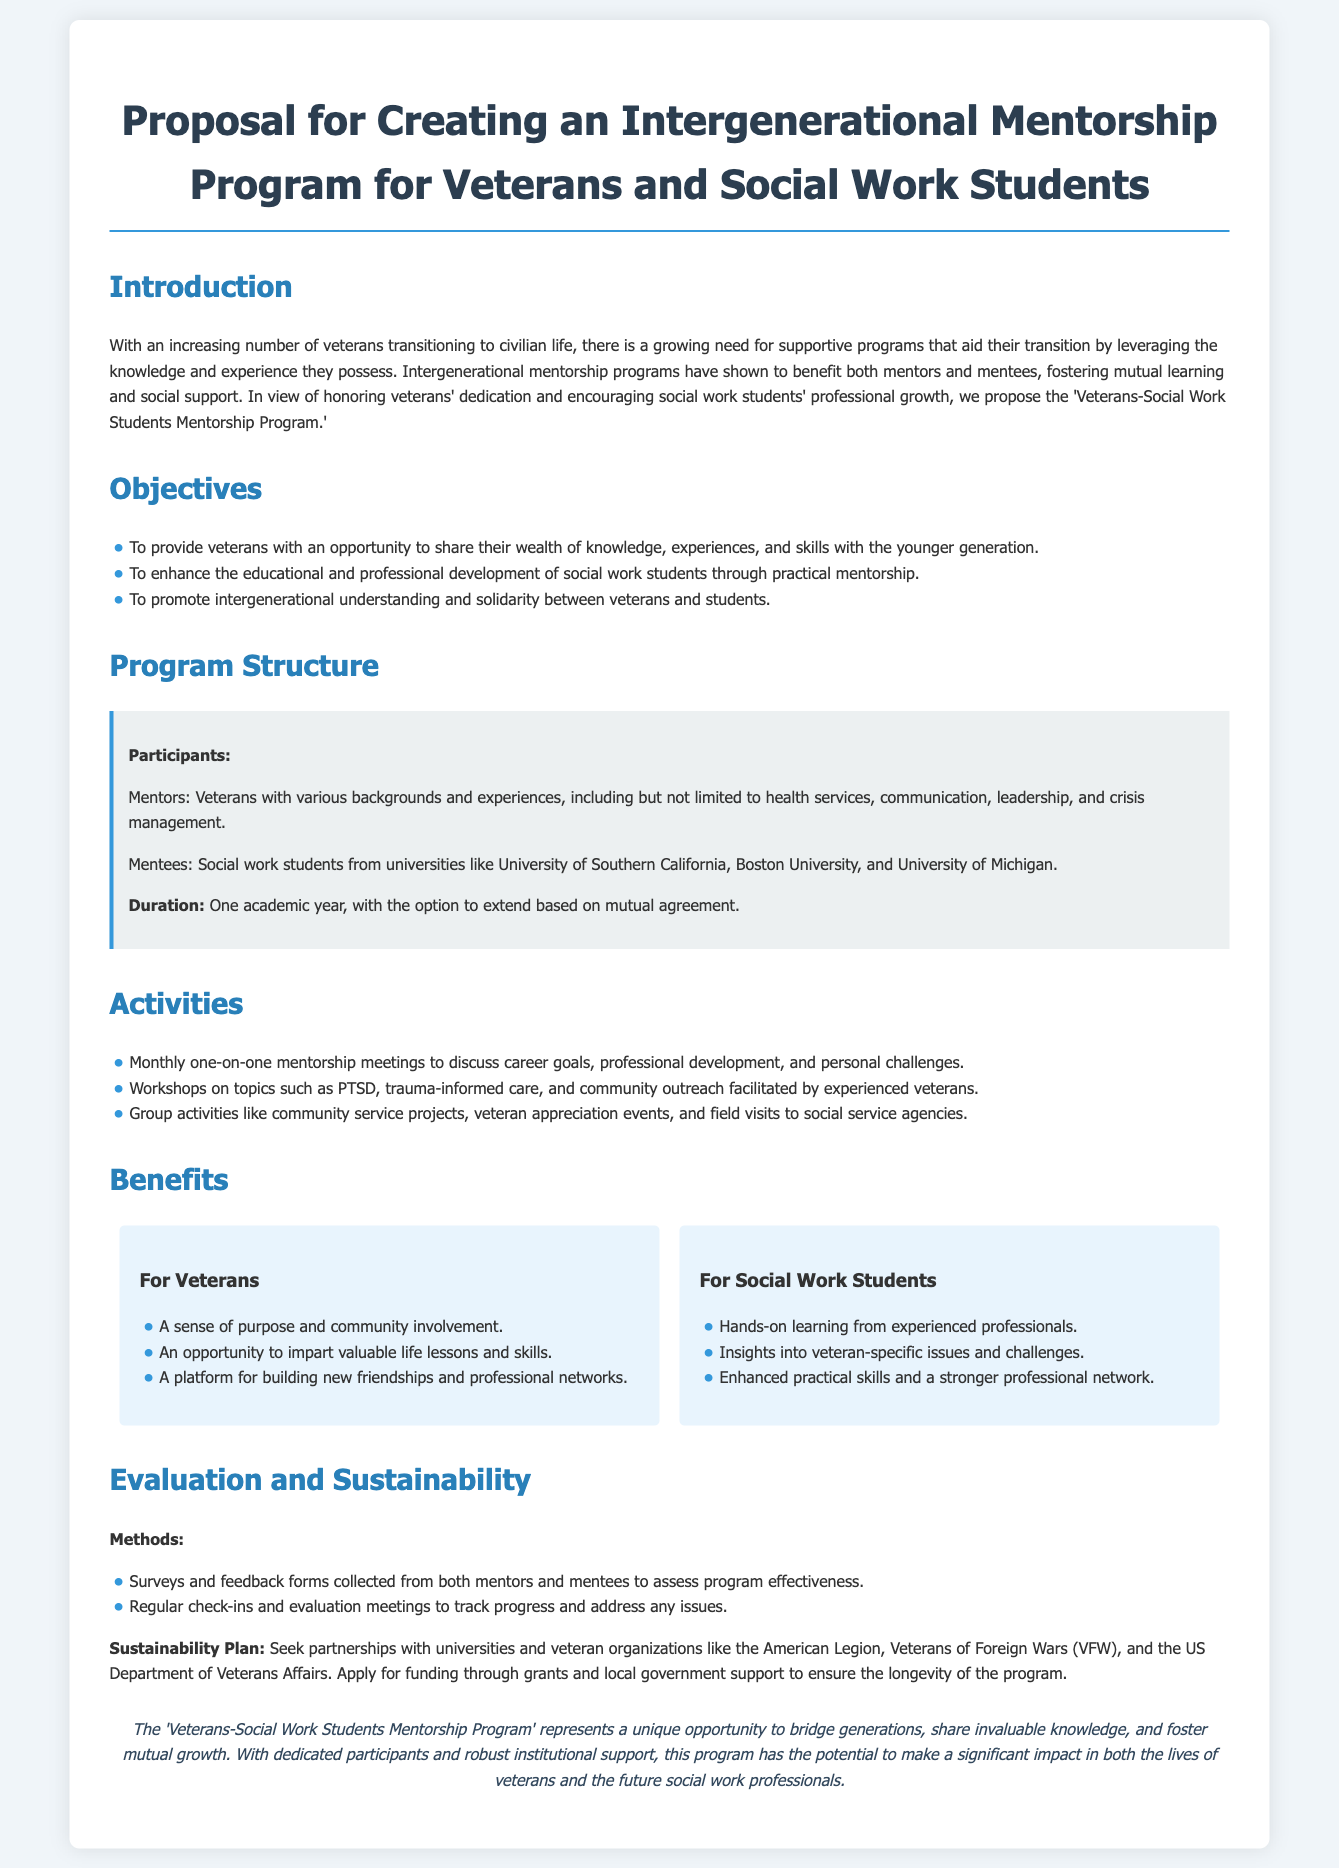What is the title of the proposal? The title of the proposal is clearly stated at the beginning of the document.
Answer: Proposal for Creating an Intergenerational Mentorship Program for Veterans and Social Work Students What is the duration of the program? The duration of the program is specified in the program structure section.
Answer: One academic year Which university is mentioned as a participant for social work students? The document lists specific universities from which social work students will be participating.
Answer: University of Southern California What are the main benefits for veterans? The document outlines the various benefits for veterans in a specific section.
Answer: A sense of purpose and community involvement What method will be used for evaluation? It discusses how the program will be assessed through specific methods.
Answer: Surveys and feedback forms How many activities are listed in the program? The number of activities mentioned in the activities section indicates engagement points.
Answer: Three What is the sustainability plan's focus? The document explains how the program will continue to operate long-term, which includes partnerships.
Answer: Seek partnerships What do mentees gain from the mentorship program? The benefits for social work students are enumerated in the benefits section.
Answer: Hands-on learning from experienced professionals How often will mentorship meetings occur? The document specifies the frequency of meetings in the activities section.
Answer: Monthly What type of program is proposed? The document explicitly categorizes the type of mentorship program being proposed.
Answer: Intergenerational mentorship program 